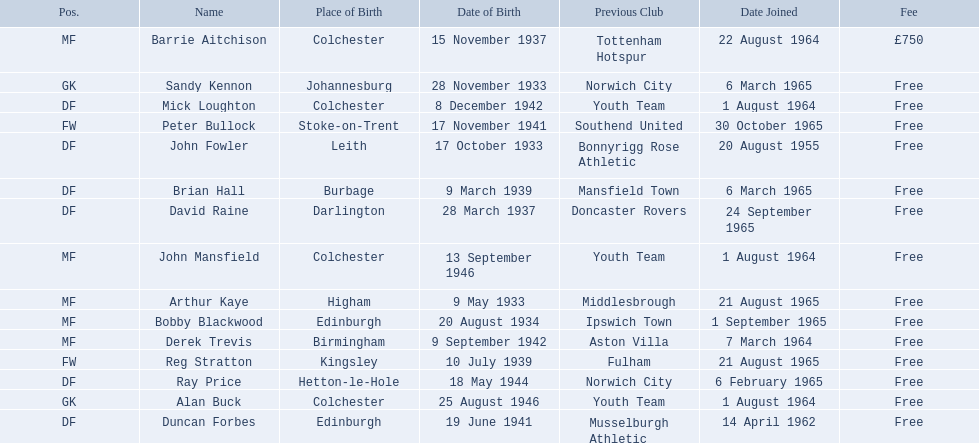When did each player join? 1 August 1964, 6 March 1965, 14 April 1962, 20 August 1955, 6 March 1965, 1 August 1964, 6 February 1965, 24 September 1965, 22 August 1964, 1 September 1965, 21 August 1965, 1 August 1964, 7 March 1964, 30 October 1965, 21 August 1965. And of those, which is the earliest join date? 20 August 1955. 